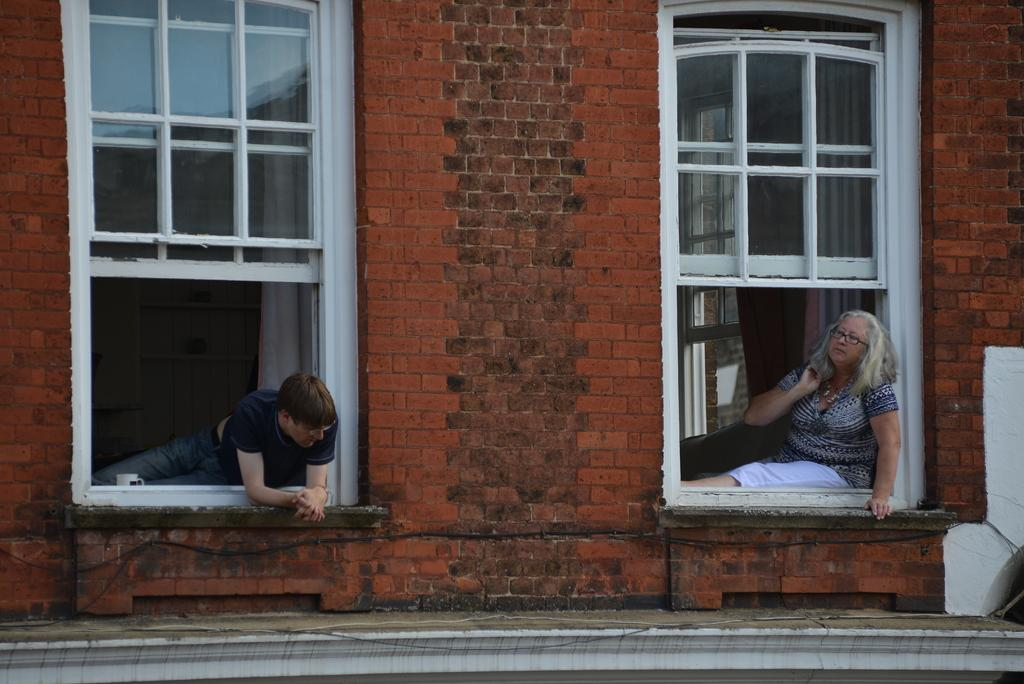What type of structure is visible in the image? There is a building in the image. How many windows can be seen on the building? The building has two windows. What is happening in the windows of the building? There is a man in one of the windows and a woman in the other window. What type of cup is the woman holding in the image? There is no cup present in the image; the woman is in a window of the building. 